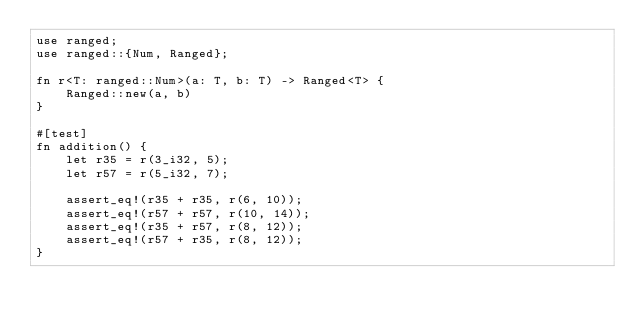Convert code to text. <code><loc_0><loc_0><loc_500><loc_500><_Rust_>use ranged;
use ranged::{Num, Ranged};

fn r<T: ranged::Num>(a: T, b: T) -> Ranged<T> {
    Ranged::new(a, b)
}

#[test]
fn addition() {
    let r35 = r(3_i32, 5);
    let r57 = r(5_i32, 7);

    assert_eq!(r35 + r35, r(6, 10));
    assert_eq!(r57 + r57, r(10, 14));
    assert_eq!(r35 + r57, r(8, 12));
    assert_eq!(r57 + r35, r(8, 12));
}
</code> 